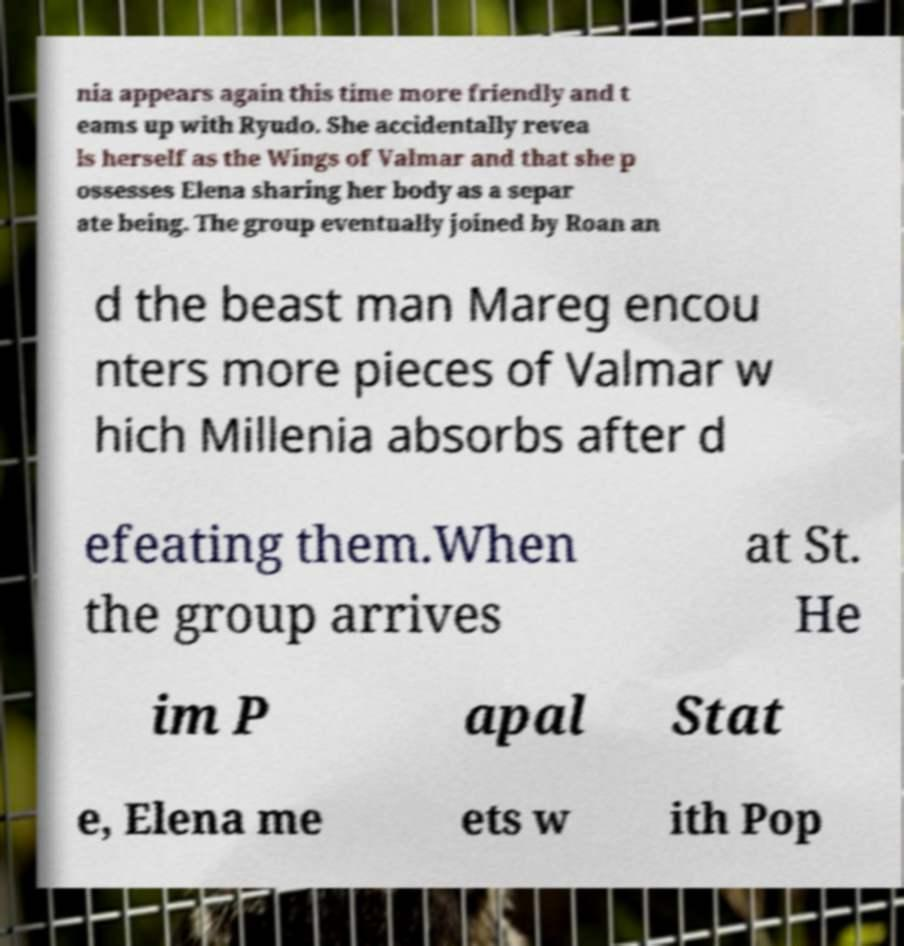Could you assist in decoding the text presented in this image and type it out clearly? nia appears again this time more friendly and t eams up with Ryudo. She accidentally revea ls herself as the Wings of Valmar and that she p ossesses Elena sharing her body as a separ ate being. The group eventually joined by Roan an d the beast man Mareg encou nters more pieces of Valmar w hich Millenia absorbs after d efeating them.When the group arrives at St. He im P apal Stat e, Elena me ets w ith Pop 